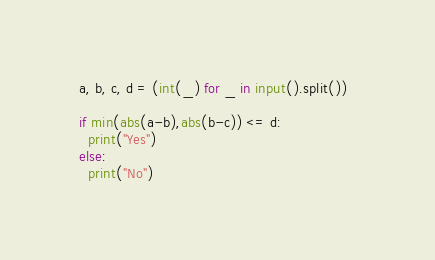<code> <loc_0><loc_0><loc_500><loc_500><_Python_>a, b, c, d = (int(_) for _ in input().split())  

if min(abs(a-b),abs(b-c)) <= d:
  print("Yes")
else:
  print("No")

</code> 